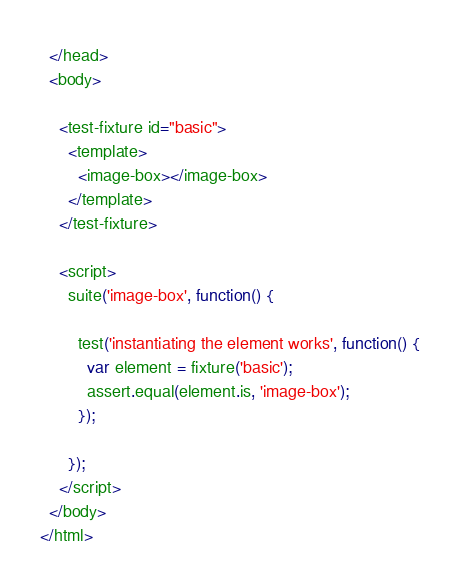Convert code to text. <code><loc_0><loc_0><loc_500><loc_500><_HTML_>  </head>
  <body>

    <test-fixture id="basic">
      <template>
        <image-box></image-box>
      </template>
    </test-fixture>

    <script>
      suite('image-box', function() {

        test('instantiating the element works', function() {
          var element = fixture('basic');
          assert.equal(element.is, 'image-box');
        });

      });
    </script>
  </body>
</html>
</code> 